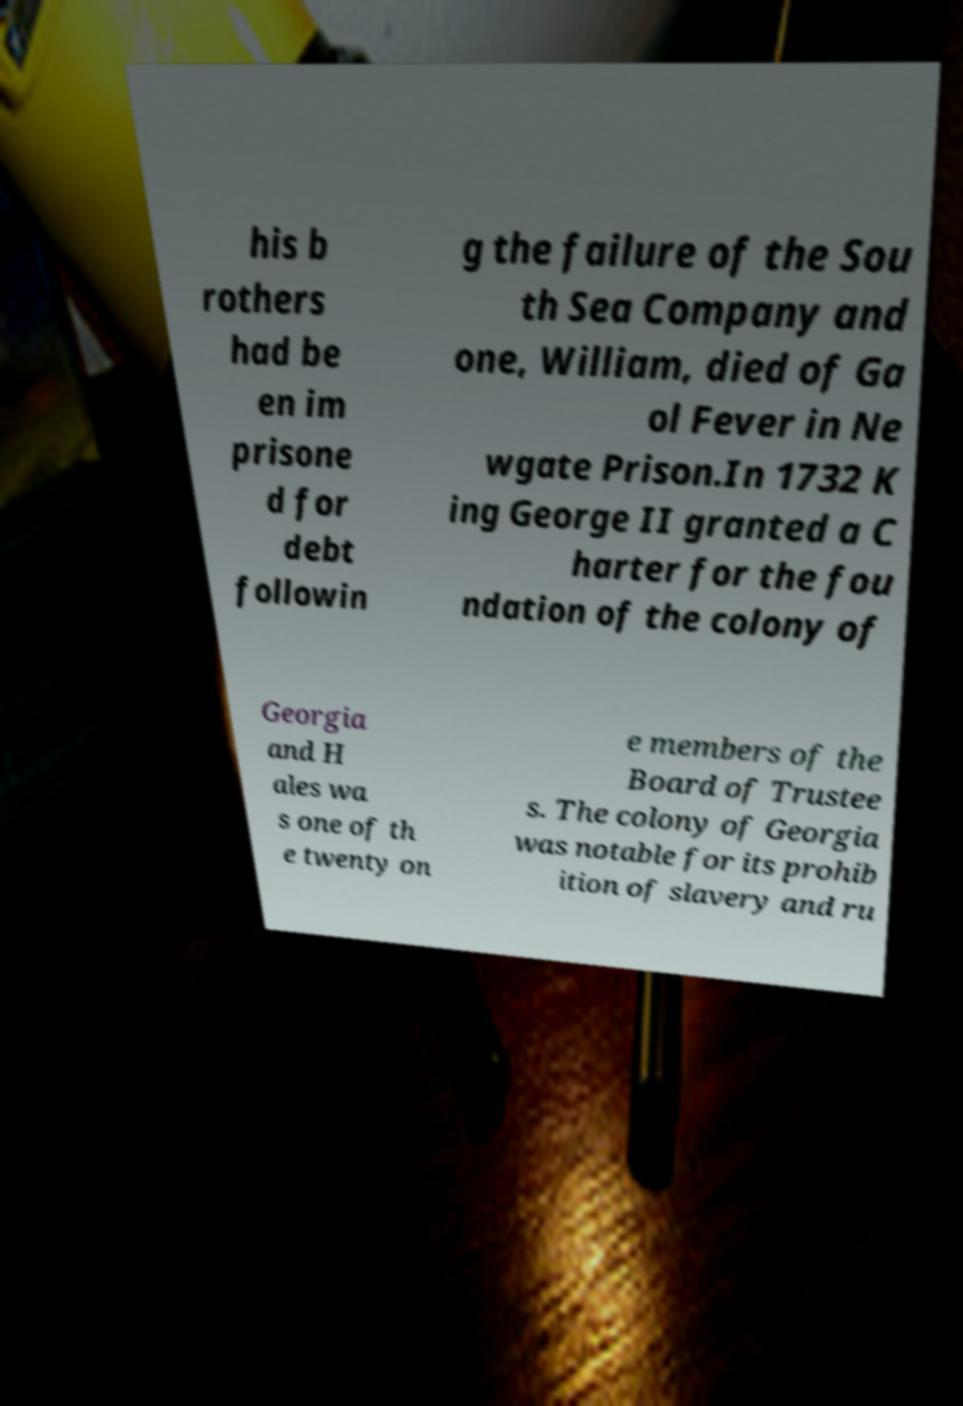There's text embedded in this image that I need extracted. Can you transcribe it verbatim? his b rothers had be en im prisone d for debt followin g the failure of the Sou th Sea Company and one, William, died of Ga ol Fever in Ne wgate Prison.In 1732 K ing George II granted a C harter for the fou ndation of the colony of Georgia and H ales wa s one of th e twenty on e members of the Board of Trustee s. The colony of Georgia was notable for its prohib ition of slavery and ru 